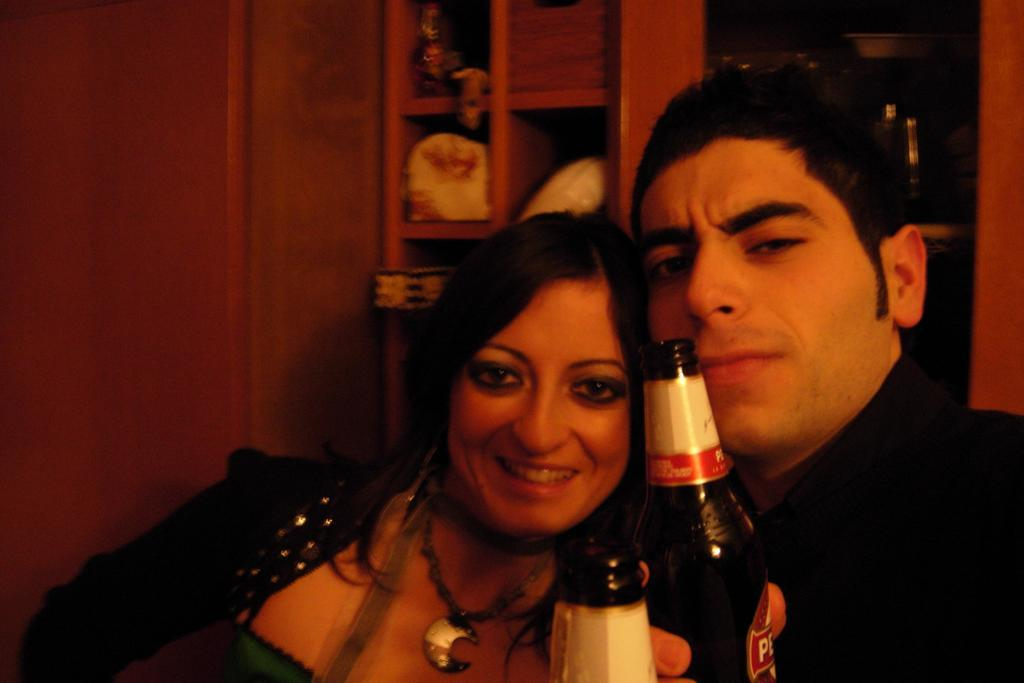How many people are in the image? There are two persons in the image. What are the two persons holding? The two persons are holding bottles. What color are the dresses worn by the persons in the image? Both persons are wearing black dresses. What can be seen in the background of the image? There is a rack filled with things in the background of the image. How long have the two persons been sleeping in the image? There is no indication of the persons sleeping in the image; they are holding bottles and wearing black dresses. 